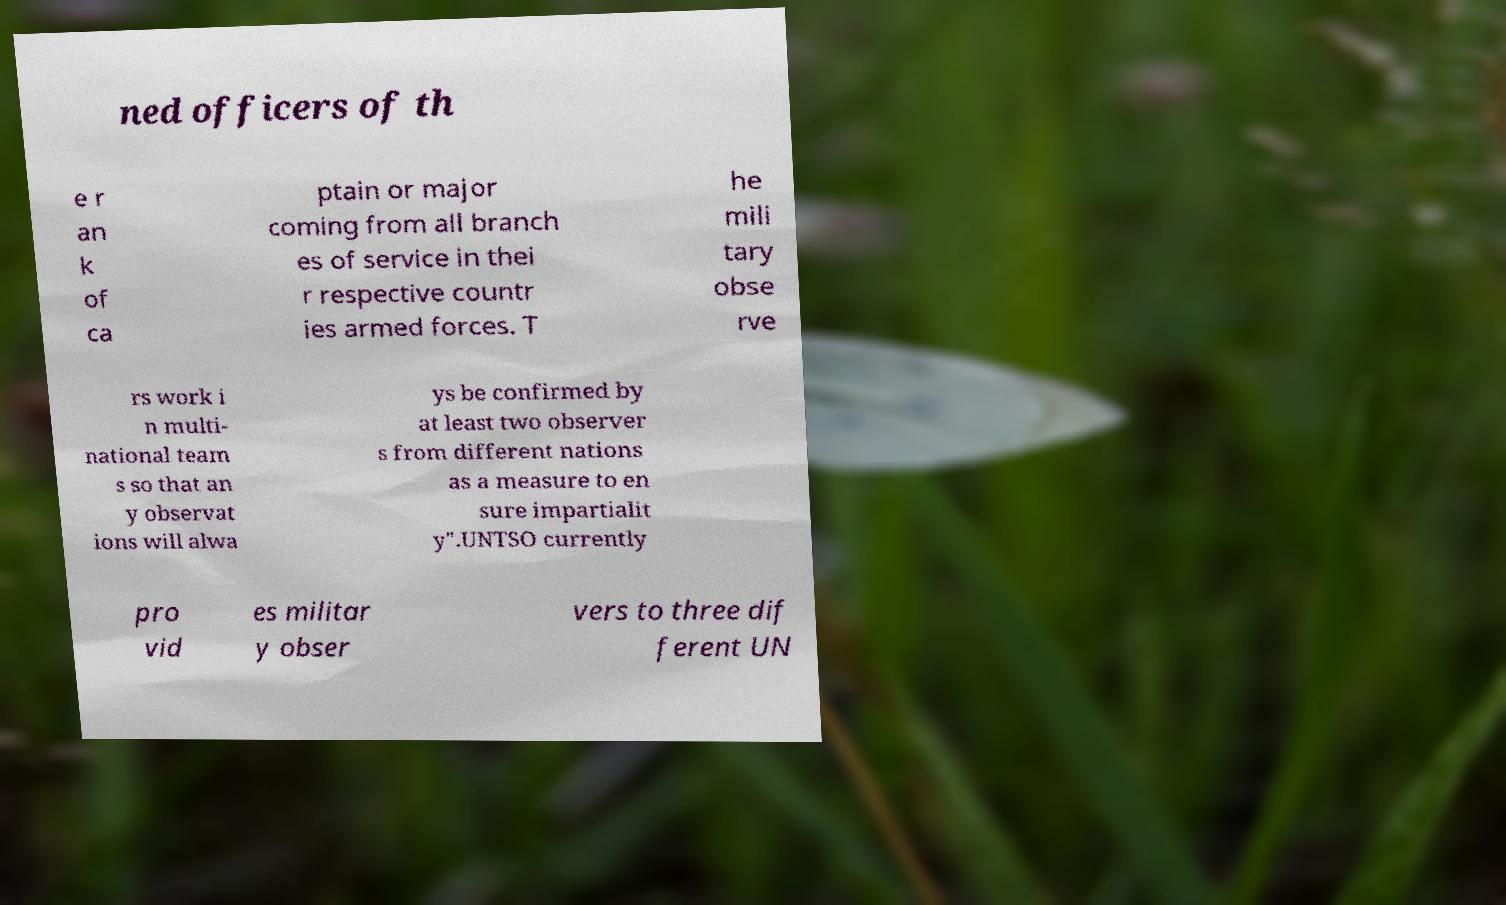Could you extract and type out the text from this image? ned officers of th e r an k of ca ptain or major coming from all branch es of service in thei r respective countr ies armed forces. T he mili tary obse rve rs work i n multi- national team s so that an y observat ions will alwa ys be confirmed by at least two observer s from different nations as a measure to en sure impartialit y".UNTSO currently pro vid es militar y obser vers to three dif ferent UN 